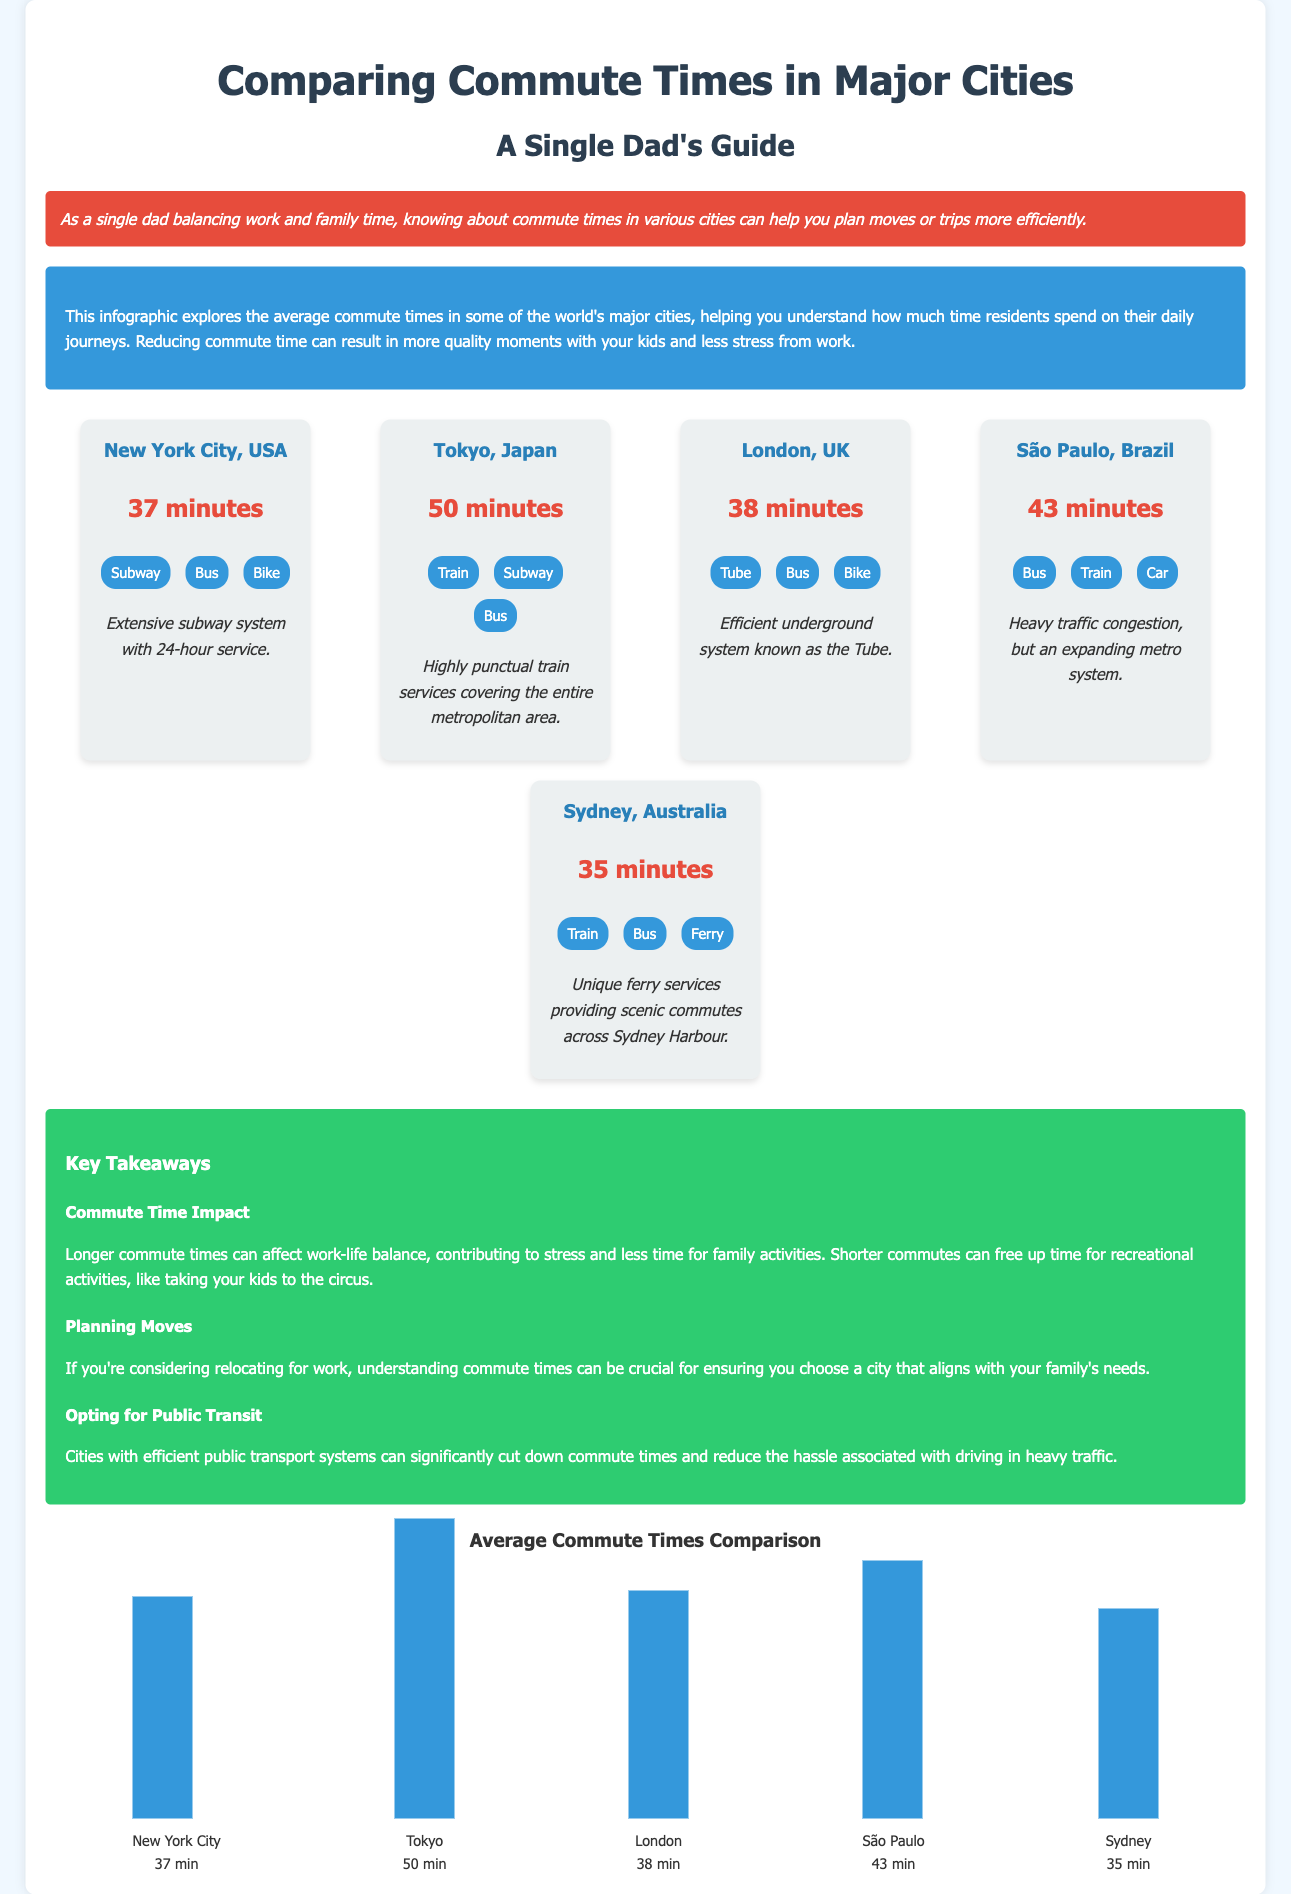What is the average commute time in New York City? The document states that the average commute time in New York City is 37 minutes.
Answer: 37 minutes What is the main transport mode in Tokyo? The infographic lists train, subway, and bus as transport modes in Tokyo, highlighting the train's significance.
Answer: Train How many minutes is the commute time in São Paulo? The commute time for São Paulo is specifically mentioned as 43 minutes.
Answer: 43 minutes Which city has the shortest average commute time? A comparison of the commute times shows that Sydney has the shortest time at 35 minutes.
Answer: Sydney What is a key takeaway regarding long commute times? The infographic indicates that longer commute times can negatively impact work-life balance and family time.
Answer: Work-life balance Which city is known for its extensive subway system? The content emphasizes New York City's extensive subway system.
Answer: New York City What is the average commute time in Tokyo? The data specifies that Tokyo has an average commute time of 50 minutes.
Answer: 50 minutes Which transport modes are listed for Sydney? The document details that Sydney utilizes train, bus, and ferry as transport modes.
Answer: Train, bus, ferry What takeaway relates to planning moves? The summary suggests understanding commute times is crucial when relocating for work.
Answer: Understanding commute times 